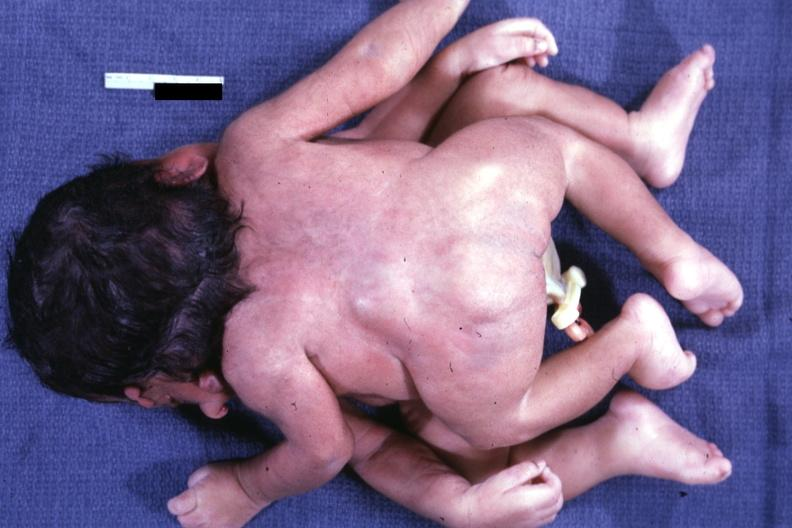what is present?
Answer the question using a single word or phrase. Cephalothoracopagus janiceps 